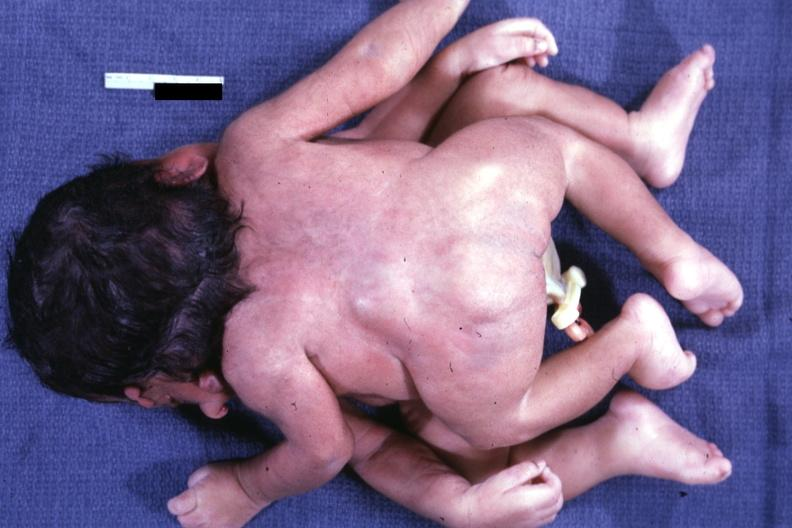what is present?
Answer the question using a single word or phrase. Cephalothoracopagus janiceps 